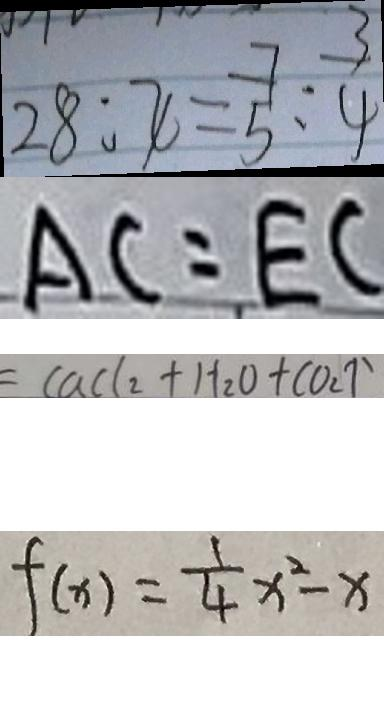<formula> <loc_0><loc_0><loc_500><loc_500>2 8 : x = \frac { 7 } { 5 } : \frac { 3 } { 4 } 
 A C = E C 
 = C a C l _ { 2 } + H _ { 2 } O + C O _ { 2 } \uparrow 
 f ( x ) = \frac { 1 } { 4 } x ^ { 2 } - x</formula> 